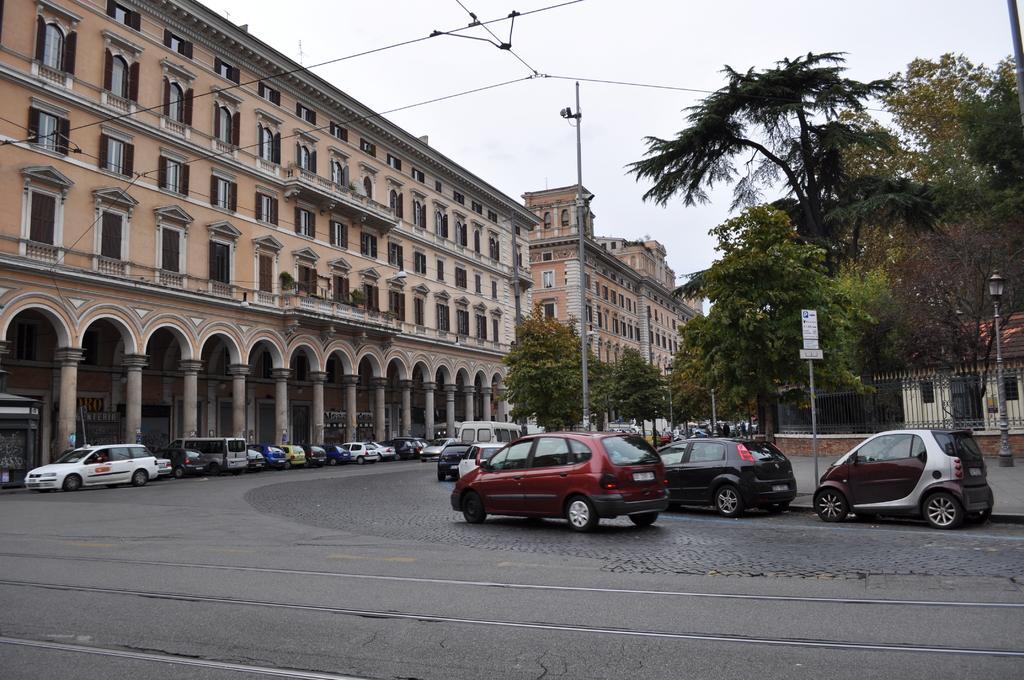In one or two sentences, can you explain what this image depicts? In this image we can see motor vehicles placed on the road, buildings, pillars, poles, cc cameras, electric cables, trees, mesh, street poles, street lights, trees and sky. 